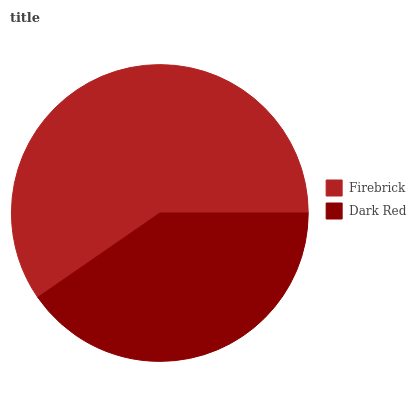Is Dark Red the minimum?
Answer yes or no. Yes. Is Firebrick the maximum?
Answer yes or no. Yes. Is Dark Red the maximum?
Answer yes or no. No. Is Firebrick greater than Dark Red?
Answer yes or no. Yes. Is Dark Red less than Firebrick?
Answer yes or no. Yes. Is Dark Red greater than Firebrick?
Answer yes or no. No. Is Firebrick less than Dark Red?
Answer yes or no. No. Is Firebrick the high median?
Answer yes or no. Yes. Is Dark Red the low median?
Answer yes or no. Yes. Is Dark Red the high median?
Answer yes or no. No. Is Firebrick the low median?
Answer yes or no. No. 